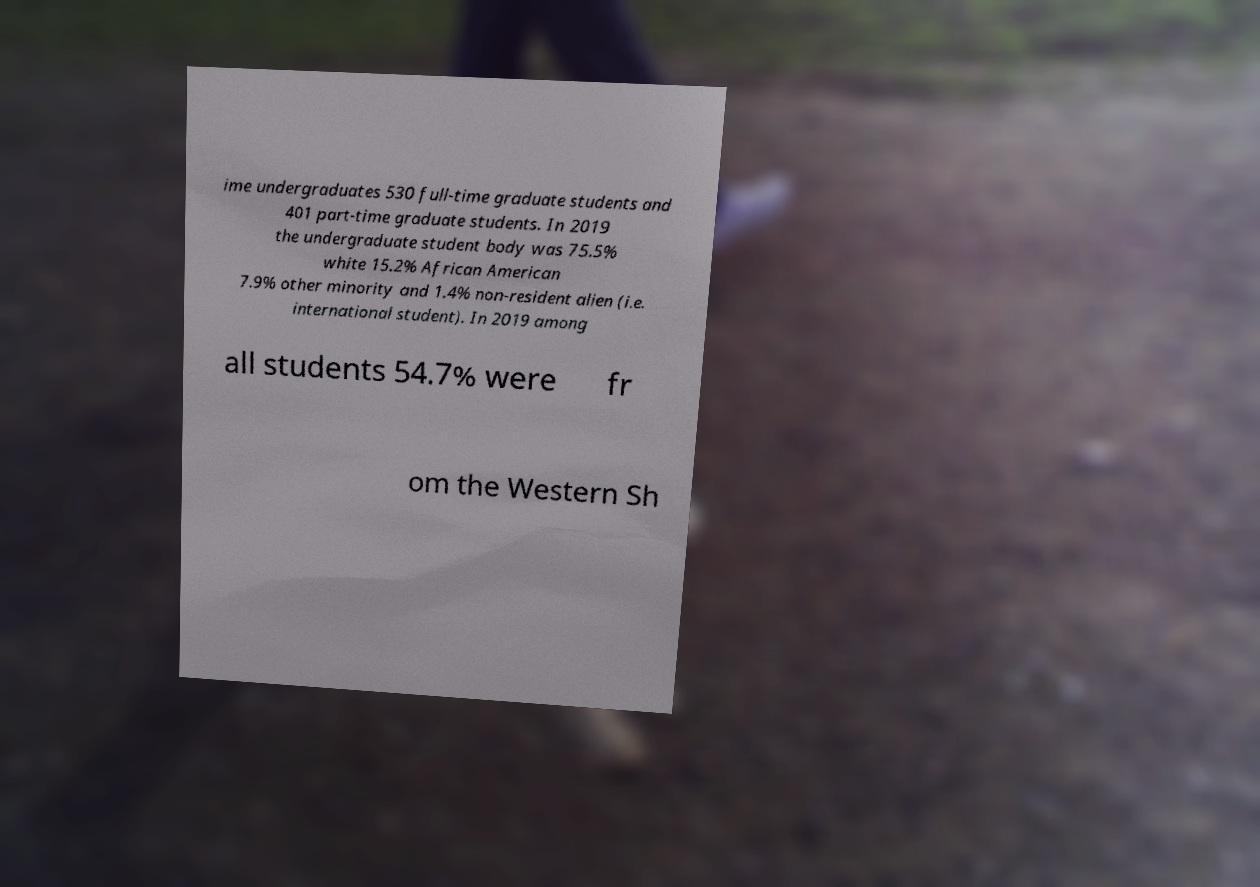I need the written content from this picture converted into text. Can you do that? ime undergraduates 530 full-time graduate students and 401 part-time graduate students. In 2019 the undergraduate student body was 75.5% white 15.2% African American 7.9% other minority and 1.4% non-resident alien (i.e. international student). In 2019 among all students 54.7% were fr om the Western Sh 